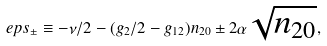Convert formula to latex. <formula><loc_0><loc_0><loc_500><loc_500>\ e p s _ { \pm } \equiv - \nu / 2 - ( g _ { 2 } / 2 - g _ { 1 2 } ) n _ { 2 0 } \pm 2 \alpha \sqrt { n _ { 2 0 } } ,</formula> 